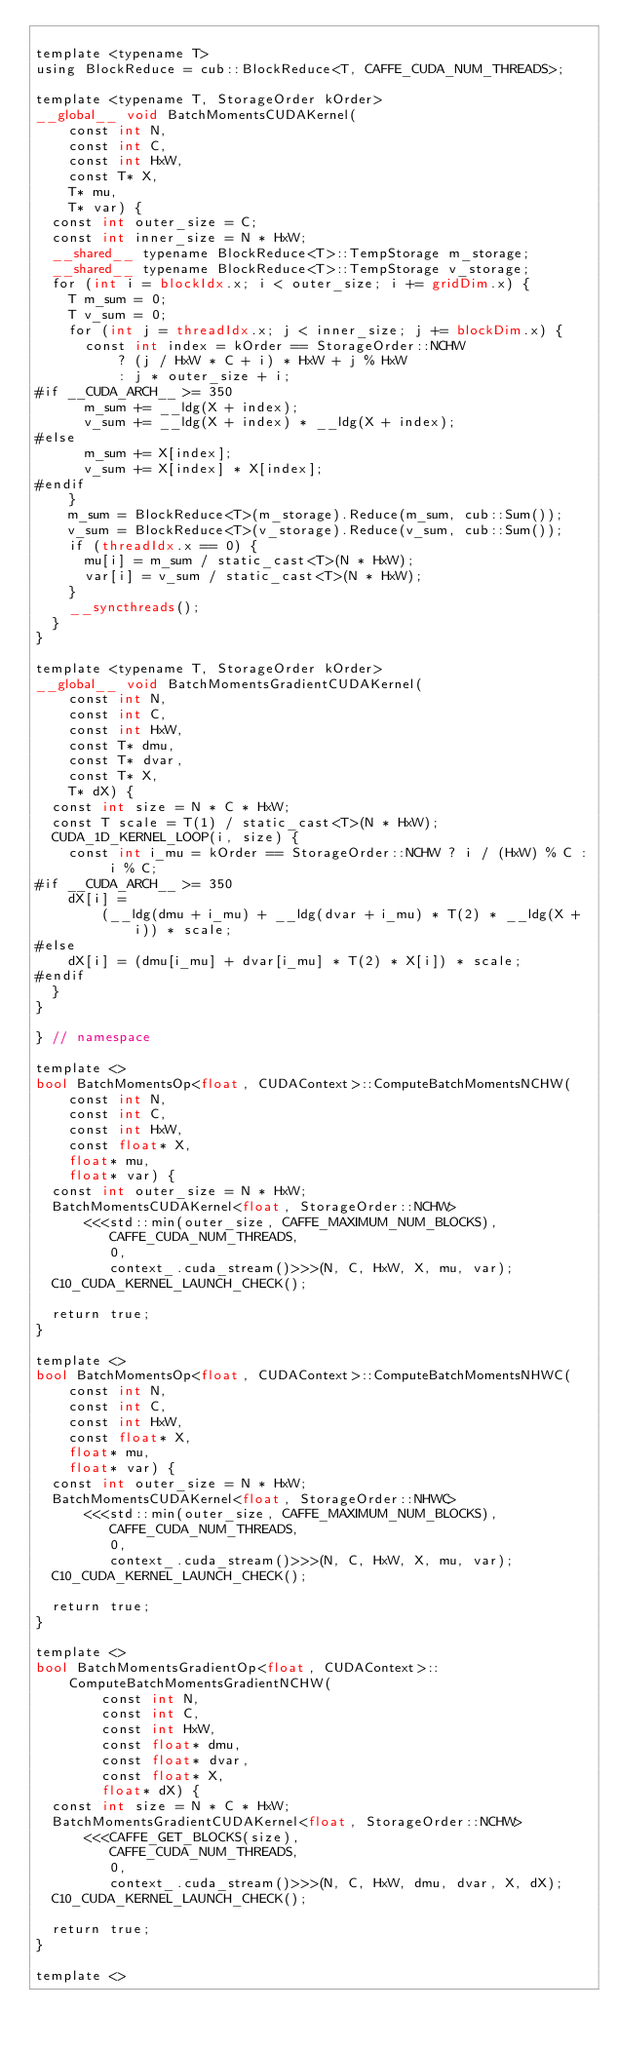<code> <loc_0><loc_0><loc_500><loc_500><_Cuda_>
template <typename T>
using BlockReduce = cub::BlockReduce<T, CAFFE_CUDA_NUM_THREADS>;

template <typename T, StorageOrder kOrder>
__global__ void BatchMomentsCUDAKernel(
    const int N,
    const int C,
    const int HxW,
    const T* X,
    T* mu,
    T* var) {
  const int outer_size = C;
  const int inner_size = N * HxW;
  __shared__ typename BlockReduce<T>::TempStorage m_storage;
  __shared__ typename BlockReduce<T>::TempStorage v_storage;
  for (int i = blockIdx.x; i < outer_size; i += gridDim.x) {
    T m_sum = 0;
    T v_sum = 0;
    for (int j = threadIdx.x; j < inner_size; j += blockDim.x) {
      const int index = kOrder == StorageOrder::NCHW
          ? (j / HxW * C + i) * HxW + j % HxW
          : j * outer_size + i;
#if __CUDA_ARCH__ >= 350
      m_sum += __ldg(X + index);
      v_sum += __ldg(X + index) * __ldg(X + index);
#else
      m_sum += X[index];
      v_sum += X[index] * X[index];
#endif
    }
    m_sum = BlockReduce<T>(m_storage).Reduce(m_sum, cub::Sum());
    v_sum = BlockReduce<T>(v_storage).Reduce(v_sum, cub::Sum());
    if (threadIdx.x == 0) {
      mu[i] = m_sum / static_cast<T>(N * HxW);
      var[i] = v_sum / static_cast<T>(N * HxW);
    }
    __syncthreads();
  }
}

template <typename T, StorageOrder kOrder>
__global__ void BatchMomentsGradientCUDAKernel(
    const int N,
    const int C,
    const int HxW,
    const T* dmu,
    const T* dvar,
    const T* X,
    T* dX) {
  const int size = N * C * HxW;
  const T scale = T(1) / static_cast<T>(N * HxW);
  CUDA_1D_KERNEL_LOOP(i, size) {
    const int i_mu = kOrder == StorageOrder::NCHW ? i / (HxW) % C : i % C;
#if __CUDA_ARCH__ >= 350
    dX[i] =
        (__ldg(dmu + i_mu) + __ldg(dvar + i_mu) * T(2) * __ldg(X + i)) * scale;
#else
    dX[i] = (dmu[i_mu] + dvar[i_mu] * T(2) * X[i]) * scale;
#endif
  }
}

} // namespace

template <>
bool BatchMomentsOp<float, CUDAContext>::ComputeBatchMomentsNCHW(
    const int N,
    const int C,
    const int HxW,
    const float* X,
    float* mu,
    float* var) {
  const int outer_size = N * HxW;
  BatchMomentsCUDAKernel<float, StorageOrder::NCHW>
      <<<std::min(outer_size, CAFFE_MAXIMUM_NUM_BLOCKS),
         CAFFE_CUDA_NUM_THREADS,
         0,
         context_.cuda_stream()>>>(N, C, HxW, X, mu, var);
  C10_CUDA_KERNEL_LAUNCH_CHECK();

  return true;
}

template <>
bool BatchMomentsOp<float, CUDAContext>::ComputeBatchMomentsNHWC(
    const int N,
    const int C,
    const int HxW,
    const float* X,
    float* mu,
    float* var) {
  const int outer_size = N * HxW;
  BatchMomentsCUDAKernel<float, StorageOrder::NHWC>
      <<<std::min(outer_size, CAFFE_MAXIMUM_NUM_BLOCKS),
         CAFFE_CUDA_NUM_THREADS,
         0,
         context_.cuda_stream()>>>(N, C, HxW, X, mu, var);
  C10_CUDA_KERNEL_LAUNCH_CHECK();

  return true;
}

template <>
bool BatchMomentsGradientOp<float, CUDAContext>::
    ComputeBatchMomentsGradientNCHW(
        const int N,
        const int C,
        const int HxW,
        const float* dmu,
        const float* dvar,
        const float* X,
        float* dX) {
  const int size = N * C * HxW;
  BatchMomentsGradientCUDAKernel<float, StorageOrder::NCHW>
      <<<CAFFE_GET_BLOCKS(size),
         CAFFE_CUDA_NUM_THREADS,
         0,
         context_.cuda_stream()>>>(N, C, HxW, dmu, dvar, X, dX);
  C10_CUDA_KERNEL_LAUNCH_CHECK();

  return true;
}

template <></code> 